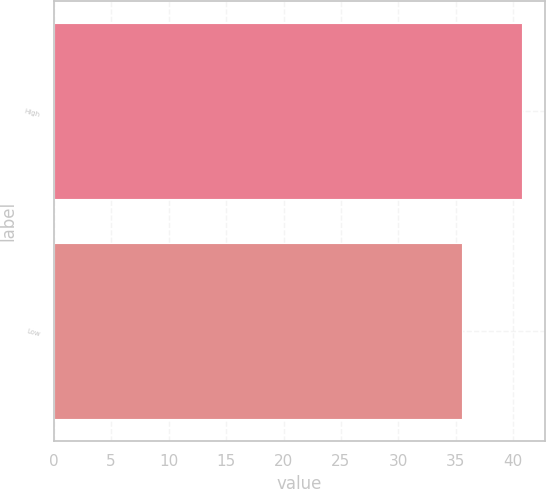Convert chart. <chart><loc_0><loc_0><loc_500><loc_500><bar_chart><fcel>High<fcel>Low<nl><fcel>40.74<fcel>35.5<nl></chart> 